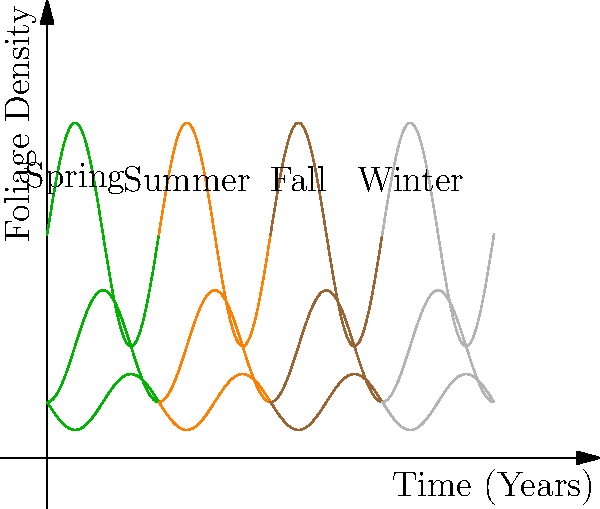During your walks in Philadelphia's parks, you notice cyclic patterns in the foliage density throughout the year. The graph shows the foliage density of three different tree species over four seasons, repeating annually. If we consider the group of cyclic permutations on these four seasons, what is the order of this group? To determine the order of the group of cyclic permutations on the four seasons, we can follow these steps:

1. Identify the elements: We have four distinct seasons - Spring, Summer, Fall, and Winter.

2. Understand cyclic permutations: A cyclic permutation rotates all elements in a fixed order. In this case, the natural order of seasons.

3. List all possible cyclic permutations:
   - Identity: (Spring, Summer, Fall, Winter)
   - One shift: (Summer, Fall, Winter, Spring)
   - Two shifts: (Fall, Winter, Spring, Summer)
   - Three shifts: (Winter, Spring, Summer, Fall)

4. Count the number of distinct permutations: We have 4 distinct permutations.

5. Recall that the order of a group is the number of elements in the group.

Therefore, the order of the group of cyclic permutations on these four seasons is 4.

This aligns with the cyclic nature of seasons observed in Philadelphia's parks, where the pattern repeats every four seasons, as shown in the graph.
Answer: 4 